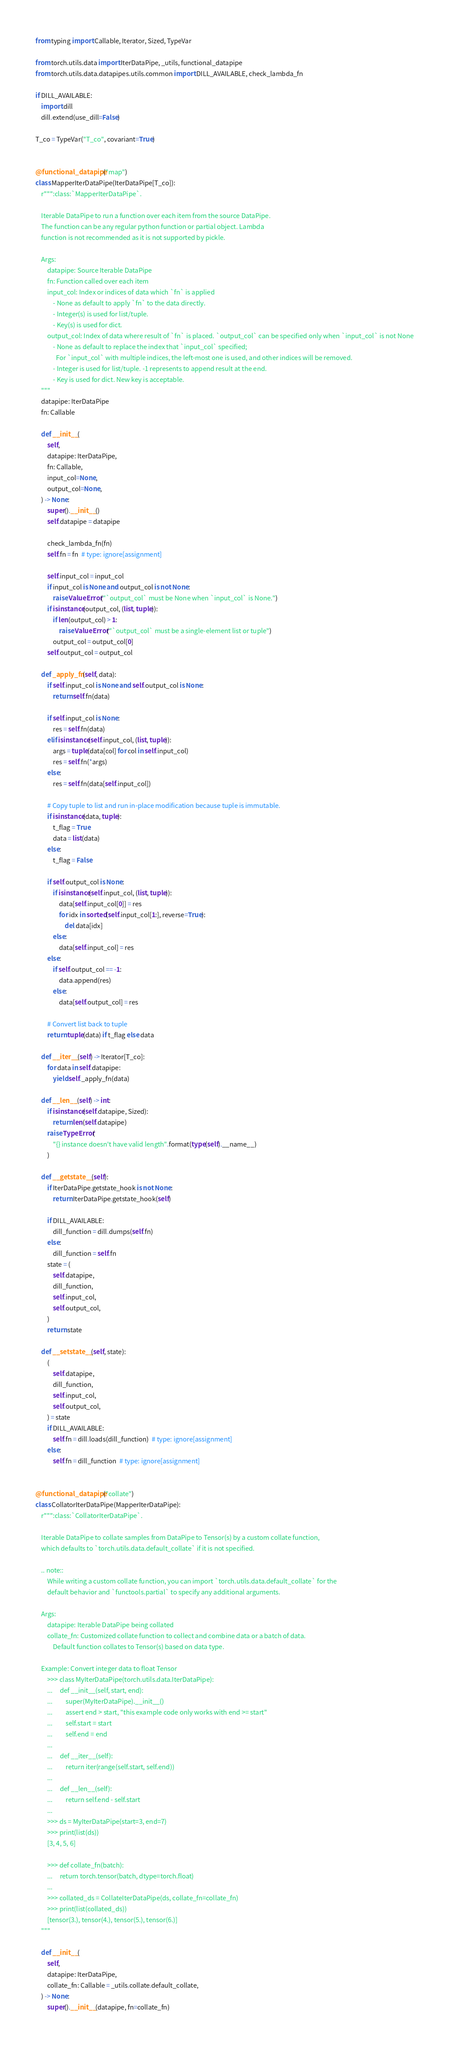Convert code to text. <code><loc_0><loc_0><loc_500><loc_500><_Python_>from typing import Callable, Iterator, Sized, TypeVar

from torch.utils.data import IterDataPipe, _utils, functional_datapipe
from torch.utils.data.datapipes.utils.common import DILL_AVAILABLE, check_lambda_fn

if DILL_AVAILABLE:
    import dill
    dill.extend(use_dill=False)

T_co = TypeVar("T_co", covariant=True)


@functional_datapipe("map")
class MapperIterDataPipe(IterDataPipe[T_co]):
    r""":class:`MapperIterDataPipe`.

    Iterable DataPipe to run a function over each item from the source DataPipe.
    The function can be any regular python function or partial object. Lambda
    function is not recommended as it is not supported by pickle.

    Args:
        datapipe: Source Iterable DataPipe
        fn: Function called over each item
        input_col: Index or indices of data which `fn` is applied
            - None as default to apply `fn` to the data directly.
            - Integer(s) is used for list/tuple.
            - Key(s) is used for dict.
        output_col: Index of data where result of `fn` is placed. `output_col` can be specified only when `input_col` is not None
            - None as default to replace the index that `input_col` specified;
              For `input_col` with multiple indices, the left-most one is used, and other indices will be removed.
            - Integer is used for list/tuple. -1 represents to append result at the end.
            - Key is used for dict. New key is acceptable.
    """
    datapipe: IterDataPipe
    fn: Callable

    def __init__(
        self,
        datapipe: IterDataPipe,
        fn: Callable,
        input_col=None,
        output_col=None,
    ) -> None:
        super().__init__()
        self.datapipe = datapipe

        check_lambda_fn(fn)
        self.fn = fn  # type: ignore[assignment]

        self.input_col = input_col
        if input_col is None and output_col is not None:
            raise ValueError("`output_col` must be None when `input_col` is None.")
        if isinstance(output_col, (list, tuple)):
            if len(output_col) > 1:
                raise ValueError("`output_col` must be a single-element list or tuple")
            output_col = output_col[0]
        self.output_col = output_col

    def _apply_fn(self, data):
        if self.input_col is None and self.output_col is None:
            return self.fn(data)

        if self.input_col is None:
            res = self.fn(data)
        elif isinstance(self.input_col, (list, tuple)):
            args = tuple(data[col] for col in self.input_col)
            res = self.fn(*args)
        else:
            res = self.fn(data[self.input_col])

        # Copy tuple to list and run in-place modification because tuple is immutable.
        if isinstance(data, tuple):
            t_flag = True
            data = list(data)
        else:
            t_flag = False

        if self.output_col is None:
            if isinstance(self.input_col, (list, tuple)):
                data[self.input_col[0]] = res
                for idx in sorted(self.input_col[1:], reverse=True):
                    del data[idx]
            else:
                data[self.input_col] = res
        else:
            if self.output_col == -1:
                data.append(res)
            else:
                data[self.output_col] = res

        # Convert list back to tuple
        return tuple(data) if t_flag else data

    def __iter__(self) -> Iterator[T_co]:
        for data in self.datapipe:
            yield self._apply_fn(data)

    def __len__(self) -> int:
        if isinstance(self.datapipe, Sized):
            return len(self.datapipe)
        raise TypeError(
            "{} instance doesn't have valid length".format(type(self).__name__)
        )

    def __getstate__(self):
        if IterDataPipe.getstate_hook is not None:
            return IterDataPipe.getstate_hook(self)

        if DILL_AVAILABLE:
            dill_function = dill.dumps(self.fn)
        else:
            dill_function = self.fn
        state = (
            self.datapipe,
            dill_function,
            self.input_col,
            self.output_col,
        )
        return state

    def __setstate__(self, state):
        (
            self.datapipe,
            dill_function,
            self.input_col,
            self.output_col,
        ) = state
        if DILL_AVAILABLE:
            self.fn = dill.loads(dill_function)  # type: ignore[assignment]
        else:
            self.fn = dill_function  # type: ignore[assignment]


@functional_datapipe("collate")
class CollatorIterDataPipe(MapperIterDataPipe):
    r""":class:`CollatorIterDataPipe`.

    Iterable DataPipe to collate samples from DataPipe to Tensor(s) by a custom collate function,
    which defaults to `torch.utils.data.default_collate` if it is not specified.

    .. note::
        While writing a custom collate function, you can import `torch.utils.data.default_collate` for the
        default behavior and `functools.partial` to specify any additional arguments.

    Args:
        datapipe: Iterable DataPipe being collated
        collate_fn: Customized collate function to collect and combine data or a batch of data.
            Default function collates to Tensor(s) based on data type.

    Example: Convert integer data to float Tensor
        >>> class MyIterDataPipe(torch.utils.data.IterDataPipe):
        ...     def __init__(self, start, end):
        ...         super(MyIterDataPipe).__init__()
        ...         assert end > start, "this example code only works with end >= start"
        ...         self.start = start
        ...         self.end = end
        ...
        ...     def __iter__(self):
        ...         return iter(range(self.start, self.end))
        ...
        ...     def __len__(self):
        ...         return self.end - self.start
        ...
        >>> ds = MyIterDataPipe(start=3, end=7)
        >>> print(list(ds))
        [3, 4, 5, 6]

        >>> def collate_fn(batch):
        ...     return torch.tensor(batch, dtype=torch.float)
        ...
        >>> collated_ds = CollateIterDataPipe(ds, collate_fn=collate_fn)
        >>> print(list(collated_ds))
        [tensor(3.), tensor(4.), tensor(5.), tensor(6.)]
    """

    def __init__(
        self,
        datapipe: IterDataPipe,
        collate_fn: Callable = _utils.collate.default_collate,
    ) -> None:
        super().__init__(datapipe, fn=collate_fn)
</code> 